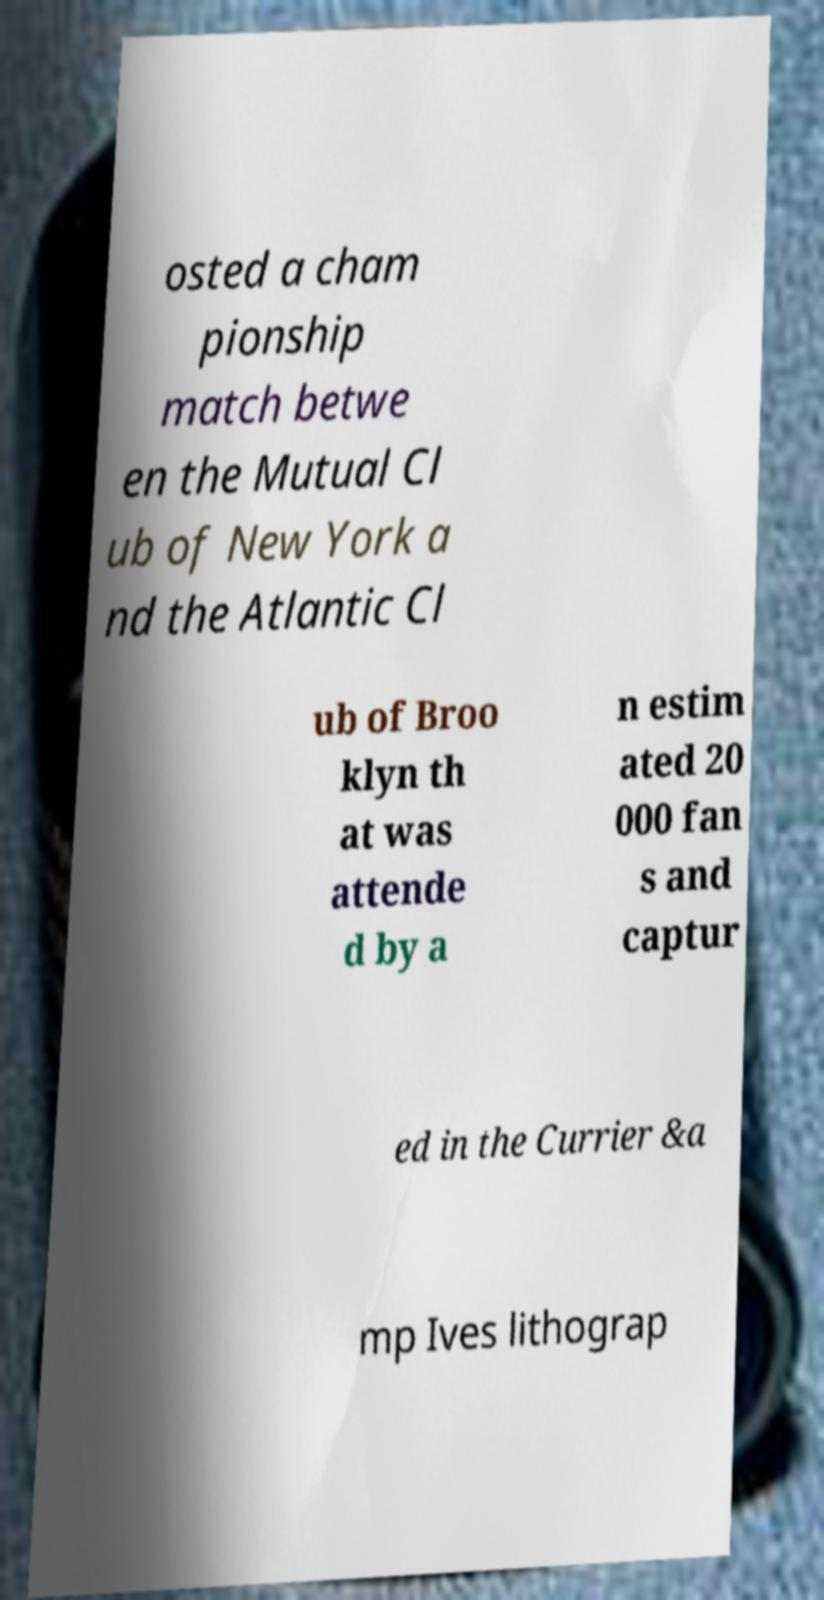Can you accurately transcribe the text from the provided image for me? osted a cham pionship match betwe en the Mutual Cl ub of New York a nd the Atlantic Cl ub of Broo klyn th at was attende d by a n estim ated 20 000 fan s and captur ed in the Currier &a mp Ives lithograp 